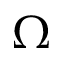Convert formula to latex. <formula><loc_0><loc_0><loc_500><loc_500>\Omega</formula> 